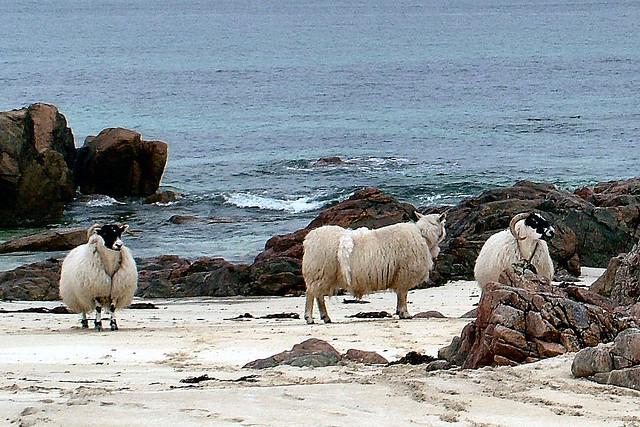Are these animals near water?
Short answer required. Yes. Is there snow?
Keep it brief. No. What is the animal thinking looking at the water?
Write a very short answer. Thirsty. 